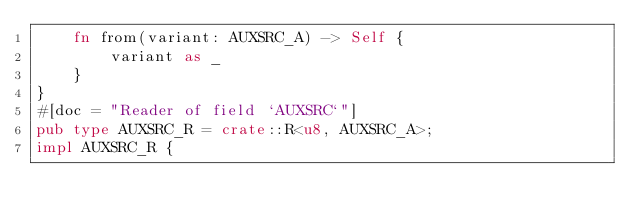<code> <loc_0><loc_0><loc_500><loc_500><_Rust_>    fn from(variant: AUXSRC_A) -> Self {
        variant as _
    }
}
#[doc = "Reader of field `AUXSRC`"]
pub type AUXSRC_R = crate::R<u8, AUXSRC_A>;
impl AUXSRC_R {</code> 